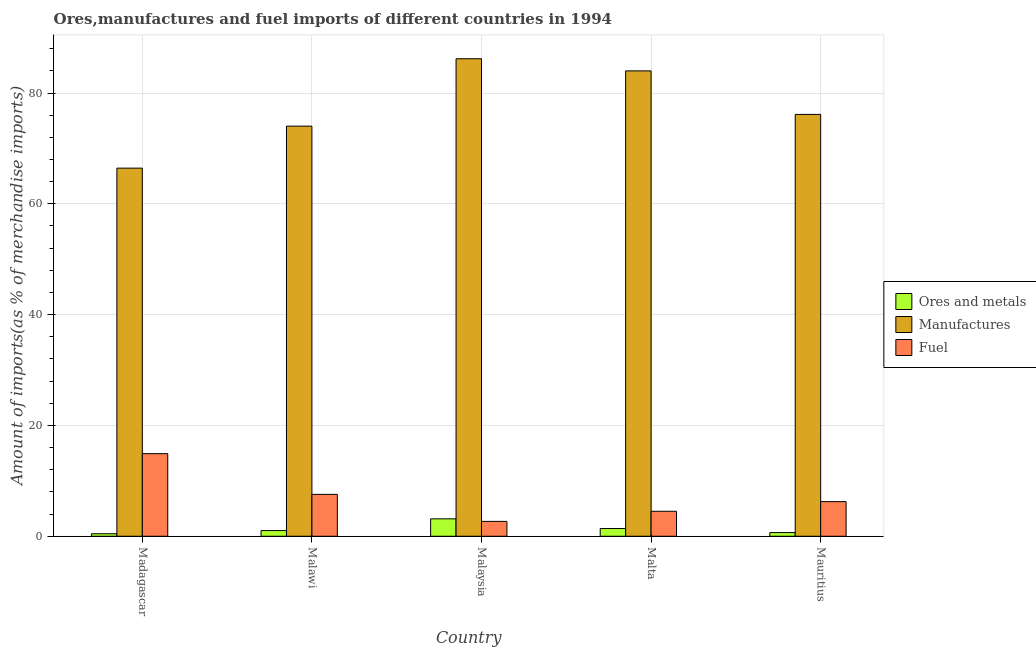How many different coloured bars are there?
Your answer should be very brief. 3. How many bars are there on the 2nd tick from the right?
Offer a very short reply. 3. What is the label of the 3rd group of bars from the left?
Offer a terse response. Malaysia. What is the percentage of fuel imports in Madagascar?
Your answer should be compact. 14.91. Across all countries, what is the maximum percentage of manufactures imports?
Offer a terse response. 86.19. Across all countries, what is the minimum percentage of fuel imports?
Your response must be concise. 2.68. In which country was the percentage of ores and metals imports maximum?
Your answer should be very brief. Malaysia. In which country was the percentage of fuel imports minimum?
Offer a terse response. Malaysia. What is the total percentage of fuel imports in the graph?
Ensure brevity in your answer.  35.9. What is the difference between the percentage of manufactures imports in Madagascar and that in Malaysia?
Provide a short and direct response. -19.74. What is the difference between the percentage of fuel imports in Madagascar and the percentage of ores and metals imports in Malta?
Provide a short and direct response. 13.51. What is the average percentage of ores and metals imports per country?
Your response must be concise. 1.34. What is the difference between the percentage of manufactures imports and percentage of fuel imports in Malta?
Offer a very short reply. 79.49. In how many countries, is the percentage of fuel imports greater than 12 %?
Your answer should be very brief. 1. What is the ratio of the percentage of ores and metals imports in Malawi to that in Mauritius?
Provide a succinct answer. 1.55. What is the difference between the highest and the second highest percentage of ores and metals imports?
Provide a succinct answer. 1.75. What is the difference between the highest and the lowest percentage of manufactures imports?
Ensure brevity in your answer.  19.74. In how many countries, is the percentage of manufactures imports greater than the average percentage of manufactures imports taken over all countries?
Your answer should be compact. 2. Is the sum of the percentage of fuel imports in Malawi and Malaysia greater than the maximum percentage of manufactures imports across all countries?
Give a very brief answer. No. What does the 1st bar from the left in Malawi represents?
Keep it short and to the point. Ores and metals. What does the 1st bar from the right in Malawi represents?
Offer a terse response. Fuel. Is it the case that in every country, the sum of the percentage of ores and metals imports and percentage of manufactures imports is greater than the percentage of fuel imports?
Your answer should be very brief. Yes. Are all the bars in the graph horizontal?
Give a very brief answer. No. How many countries are there in the graph?
Give a very brief answer. 5. What is the difference between two consecutive major ticks on the Y-axis?
Provide a succinct answer. 20. Does the graph contain grids?
Give a very brief answer. Yes. How are the legend labels stacked?
Keep it short and to the point. Vertical. What is the title of the graph?
Keep it short and to the point. Ores,manufactures and fuel imports of different countries in 1994. What is the label or title of the Y-axis?
Ensure brevity in your answer.  Amount of imports(as % of merchandise imports). What is the Amount of imports(as % of merchandise imports) in Ores and metals in Madagascar?
Make the answer very short. 0.45. What is the Amount of imports(as % of merchandise imports) in Manufactures in Madagascar?
Keep it short and to the point. 66.44. What is the Amount of imports(as % of merchandise imports) of Fuel in Madagascar?
Your answer should be very brief. 14.91. What is the Amount of imports(as % of merchandise imports) in Ores and metals in Malawi?
Keep it short and to the point. 1.03. What is the Amount of imports(as % of merchandise imports) in Manufactures in Malawi?
Make the answer very short. 74.02. What is the Amount of imports(as % of merchandise imports) of Fuel in Malawi?
Keep it short and to the point. 7.56. What is the Amount of imports(as % of merchandise imports) of Ores and metals in Malaysia?
Your answer should be very brief. 3.14. What is the Amount of imports(as % of merchandise imports) in Manufactures in Malaysia?
Offer a very short reply. 86.19. What is the Amount of imports(as % of merchandise imports) of Fuel in Malaysia?
Give a very brief answer. 2.68. What is the Amount of imports(as % of merchandise imports) in Ores and metals in Malta?
Give a very brief answer. 1.39. What is the Amount of imports(as % of merchandise imports) of Manufactures in Malta?
Offer a very short reply. 84. What is the Amount of imports(as % of merchandise imports) of Fuel in Malta?
Your answer should be very brief. 4.51. What is the Amount of imports(as % of merchandise imports) of Ores and metals in Mauritius?
Make the answer very short. 0.66. What is the Amount of imports(as % of merchandise imports) in Manufactures in Mauritius?
Offer a terse response. 76.14. What is the Amount of imports(as % of merchandise imports) in Fuel in Mauritius?
Your answer should be compact. 6.25. Across all countries, what is the maximum Amount of imports(as % of merchandise imports) in Ores and metals?
Offer a terse response. 3.14. Across all countries, what is the maximum Amount of imports(as % of merchandise imports) in Manufactures?
Provide a succinct answer. 86.19. Across all countries, what is the maximum Amount of imports(as % of merchandise imports) of Fuel?
Make the answer very short. 14.91. Across all countries, what is the minimum Amount of imports(as % of merchandise imports) of Ores and metals?
Give a very brief answer. 0.45. Across all countries, what is the minimum Amount of imports(as % of merchandise imports) of Manufactures?
Ensure brevity in your answer.  66.44. Across all countries, what is the minimum Amount of imports(as % of merchandise imports) in Fuel?
Provide a succinct answer. 2.68. What is the total Amount of imports(as % of merchandise imports) of Ores and metals in the graph?
Make the answer very short. 6.68. What is the total Amount of imports(as % of merchandise imports) in Manufactures in the graph?
Provide a short and direct response. 386.79. What is the total Amount of imports(as % of merchandise imports) of Fuel in the graph?
Make the answer very short. 35.9. What is the difference between the Amount of imports(as % of merchandise imports) in Ores and metals in Madagascar and that in Malawi?
Your answer should be compact. -0.57. What is the difference between the Amount of imports(as % of merchandise imports) in Manufactures in Madagascar and that in Malawi?
Offer a terse response. -7.58. What is the difference between the Amount of imports(as % of merchandise imports) of Fuel in Madagascar and that in Malawi?
Your response must be concise. 7.35. What is the difference between the Amount of imports(as % of merchandise imports) of Ores and metals in Madagascar and that in Malaysia?
Give a very brief answer. -2.69. What is the difference between the Amount of imports(as % of merchandise imports) in Manufactures in Madagascar and that in Malaysia?
Your response must be concise. -19.74. What is the difference between the Amount of imports(as % of merchandise imports) in Fuel in Madagascar and that in Malaysia?
Give a very brief answer. 12.23. What is the difference between the Amount of imports(as % of merchandise imports) of Ores and metals in Madagascar and that in Malta?
Provide a succinct answer. -0.94. What is the difference between the Amount of imports(as % of merchandise imports) of Manufactures in Madagascar and that in Malta?
Offer a terse response. -17.55. What is the difference between the Amount of imports(as % of merchandise imports) of Fuel in Madagascar and that in Malta?
Provide a succinct answer. 10.4. What is the difference between the Amount of imports(as % of merchandise imports) in Ores and metals in Madagascar and that in Mauritius?
Keep it short and to the point. -0.21. What is the difference between the Amount of imports(as % of merchandise imports) of Manufactures in Madagascar and that in Mauritius?
Your answer should be very brief. -9.7. What is the difference between the Amount of imports(as % of merchandise imports) in Fuel in Madagascar and that in Mauritius?
Provide a short and direct response. 8.66. What is the difference between the Amount of imports(as % of merchandise imports) of Ores and metals in Malawi and that in Malaysia?
Make the answer very short. -2.12. What is the difference between the Amount of imports(as % of merchandise imports) of Manufactures in Malawi and that in Malaysia?
Provide a succinct answer. -12.16. What is the difference between the Amount of imports(as % of merchandise imports) in Fuel in Malawi and that in Malaysia?
Provide a short and direct response. 4.87. What is the difference between the Amount of imports(as % of merchandise imports) in Ores and metals in Malawi and that in Malta?
Your answer should be very brief. -0.37. What is the difference between the Amount of imports(as % of merchandise imports) of Manufactures in Malawi and that in Malta?
Give a very brief answer. -9.97. What is the difference between the Amount of imports(as % of merchandise imports) in Fuel in Malawi and that in Malta?
Keep it short and to the point. 3.05. What is the difference between the Amount of imports(as % of merchandise imports) of Ores and metals in Malawi and that in Mauritius?
Give a very brief answer. 0.36. What is the difference between the Amount of imports(as % of merchandise imports) in Manufactures in Malawi and that in Mauritius?
Your answer should be very brief. -2.12. What is the difference between the Amount of imports(as % of merchandise imports) of Fuel in Malawi and that in Mauritius?
Keep it short and to the point. 1.31. What is the difference between the Amount of imports(as % of merchandise imports) of Ores and metals in Malaysia and that in Malta?
Keep it short and to the point. 1.75. What is the difference between the Amount of imports(as % of merchandise imports) in Manufactures in Malaysia and that in Malta?
Offer a terse response. 2.19. What is the difference between the Amount of imports(as % of merchandise imports) of Fuel in Malaysia and that in Malta?
Give a very brief answer. -1.82. What is the difference between the Amount of imports(as % of merchandise imports) of Ores and metals in Malaysia and that in Mauritius?
Keep it short and to the point. 2.48. What is the difference between the Amount of imports(as % of merchandise imports) of Manufactures in Malaysia and that in Mauritius?
Offer a terse response. 10.05. What is the difference between the Amount of imports(as % of merchandise imports) of Fuel in Malaysia and that in Mauritius?
Offer a terse response. -3.57. What is the difference between the Amount of imports(as % of merchandise imports) of Ores and metals in Malta and that in Mauritius?
Your response must be concise. 0.73. What is the difference between the Amount of imports(as % of merchandise imports) of Manufactures in Malta and that in Mauritius?
Keep it short and to the point. 7.86. What is the difference between the Amount of imports(as % of merchandise imports) of Fuel in Malta and that in Mauritius?
Provide a short and direct response. -1.74. What is the difference between the Amount of imports(as % of merchandise imports) of Ores and metals in Madagascar and the Amount of imports(as % of merchandise imports) of Manufactures in Malawi?
Keep it short and to the point. -73.57. What is the difference between the Amount of imports(as % of merchandise imports) in Ores and metals in Madagascar and the Amount of imports(as % of merchandise imports) in Fuel in Malawi?
Your answer should be very brief. -7.1. What is the difference between the Amount of imports(as % of merchandise imports) of Manufactures in Madagascar and the Amount of imports(as % of merchandise imports) of Fuel in Malawi?
Your answer should be compact. 58.89. What is the difference between the Amount of imports(as % of merchandise imports) of Ores and metals in Madagascar and the Amount of imports(as % of merchandise imports) of Manufactures in Malaysia?
Provide a succinct answer. -85.73. What is the difference between the Amount of imports(as % of merchandise imports) in Ores and metals in Madagascar and the Amount of imports(as % of merchandise imports) in Fuel in Malaysia?
Provide a succinct answer. -2.23. What is the difference between the Amount of imports(as % of merchandise imports) of Manufactures in Madagascar and the Amount of imports(as % of merchandise imports) of Fuel in Malaysia?
Your response must be concise. 63.76. What is the difference between the Amount of imports(as % of merchandise imports) of Ores and metals in Madagascar and the Amount of imports(as % of merchandise imports) of Manufactures in Malta?
Your response must be concise. -83.54. What is the difference between the Amount of imports(as % of merchandise imports) of Ores and metals in Madagascar and the Amount of imports(as % of merchandise imports) of Fuel in Malta?
Your answer should be compact. -4.05. What is the difference between the Amount of imports(as % of merchandise imports) in Manufactures in Madagascar and the Amount of imports(as % of merchandise imports) in Fuel in Malta?
Ensure brevity in your answer.  61.94. What is the difference between the Amount of imports(as % of merchandise imports) in Ores and metals in Madagascar and the Amount of imports(as % of merchandise imports) in Manufactures in Mauritius?
Make the answer very short. -75.69. What is the difference between the Amount of imports(as % of merchandise imports) in Ores and metals in Madagascar and the Amount of imports(as % of merchandise imports) in Fuel in Mauritius?
Your answer should be compact. -5.8. What is the difference between the Amount of imports(as % of merchandise imports) of Manufactures in Madagascar and the Amount of imports(as % of merchandise imports) of Fuel in Mauritius?
Your response must be concise. 60.19. What is the difference between the Amount of imports(as % of merchandise imports) of Ores and metals in Malawi and the Amount of imports(as % of merchandise imports) of Manufactures in Malaysia?
Offer a very short reply. -85.16. What is the difference between the Amount of imports(as % of merchandise imports) in Ores and metals in Malawi and the Amount of imports(as % of merchandise imports) in Fuel in Malaysia?
Give a very brief answer. -1.66. What is the difference between the Amount of imports(as % of merchandise imports) in Manufactures in Malawi and the Amount of imports(as % of merchandise imports) in Fuel in Malaysia?
Offer a very short reply. 71.34. What is the difference between the Amount of imports(as % of merchandise imports) of Ores and metals in Malawi and the Amount of imports(as % of merchandise imports) of Manufactures in Malta?
Give a very brief answer. -82.97. What is the difference between the Amount of imports(as % of merchandise imports) in Ores and metals in Malawi and the Amount of imports(as % of merchandise imports) in Fuel in Malta?
Ensure brevity in your answer.  -3.48. What is the difference between the Amount of imports(as % of merchandise imports) of Manufactures in Malawi and the Amount of imports(as % of merchandise imports) of Fuel in Malta?
Make the answer very short. 69.52. What is the difference between the Amount of imports(as % of merchandise imports) of Ores and metals in Malawi and the Amount of imports(as % of merchandise imports) of Manufactures in Mauritius?
Your answer should be very brief. -75.12. What is the difference between the Amount of imports(as % of merchandise imports) in Ores and metals in Malawi and the Amount of imports(as % of merchandise imports) in Fuel in Mauritius?
Your answer should be very brief. -5.22. What is the difference between the Amount of imports(as % of merchandise imports) of Manufactures in Malawi and the Amount of imports(as % of merchandise imports) of Fuel in Mauritius?
Keep it short and to the point. 67.77. What is the difference between the Amount of imports(as % of merchandise imports) in Ores and metals in Malaysia and the Amount of imports(as % of merchandise imports) in Manufactures in Malta?
Make the answer very short. -80.85. What is the difference between the Amount of imports(as % of merchandise imports) in Ores and metals in Malaysia and the Amount of imports(as % of merchandise imports) in Fuel in Malta?
Provide a short and direct response. -1.36. What is the difference between the Amount of imports(as % of merchandise imports) of Manufactures in Malaysia and the Amount of imports(as % of merchandise imports) of Fuel in Malta?
Keep it short and to the point. 81.68. What is the difference between the Amount of imports(as % of merchandise imports) in Ores and metals in Malaysia and the Amount of imports(as % of merchandise imports) in Manufactures in Mauritius?
Provide a succinct answer. -73. What is the difference between the Amount of imports(as % of merchandise imports) of Ores and metals in Malaysia and the Amount of imports(as % of merchandise imports) of Fuel in Mauritius?
Your response must be concise. -3.11. What is the difference between the Amount of imports(as % of merchandise imports) of Manufactures in Malaysia and the Amount of imports(as % of merchandise imports) of Fuel in Mauritius?
Give a very brief answer. 79.94. What is the difference between the Amount of imports(as % of merchandise imports) in Ores and metals in Malta and the Amount of imports(as % of merchandise imports) in Manufactures in Mauritius?
Your response must be concise. -74.75. What is the difference between the Amount of imports(as % of merchandise imports) of Ores and metals in Malta and the Amount of imports(as % of merchandise imports) of Fuel in Mauritius?
Ensure brevity in your answer.  -4.86. What is the difference between the Amount of imports(as % of merchandise imports) of Manufactures in Malta and the Amount of imports(as % of merchandise imports) of Fuel in Mauritius?
Offer a terse response. 77.75. What is the average Amount of imports(as % of merchandise imports) of Ores and metals per country?
Offer a very short reply. 1.34. What is the average Amount of imports(as % of merchandise imports) in Manufactures per country?
Your answer should be very brief. 77.36. What is the average Amount of imports(as % of merchandise imports) in Fuel per country?
Your answer should be very brief. 7.18. What is the difference between the Amount of imports(as % of merchandise imports) in Ores and metals and Amount of imports(as % of merchandise imports) in Manufactures in Madagascar?
Your answer should be very brief. -65.99. What is the difference between the Amount of imports(as % of merchandise imports) of Ores and metals and Amount of imports(as % of merchandise imports) of Fuel in Madagascar?
Provide a succinct answer. -14.46. What is the difference between the Amount of imports(as % of merchandise imports) of Manufactures and Amount of imports(as % of merchandise imports) of Fuel in Madagascar?
Provide a short and direct response. 51.53. What is the difference between the Amount of imports(as % of merchandise imports) in Ores and metals and Amount of imports(as % of merchandise imports) in Manufactures in Malawi?
Offer a terse response. -73. What is the difference between the Amount of imports(as % of merchandise imports) of Ores and metals and Amount of imports(as % of merchandise imports) of Fuel in Malawi?
Your answer should be compact. -6.53. What is the difference between the Amount of imports(as % of merchandise imports) in Manufactures and Amount of imports(as % of merchandise imports) in Fuel in Malawi?
Your answer should be very brief. 66.47. What is the difference between the Amount of imports(as % of merchandise imports) in Ores and metals and Amount of imports(as % of merchandise imports) in Manufactures in Malaysia?
Your answer should be very brief. -83.04. What is the difference between the Amount of imports(as % of merchandise imports) of Ores and metals and Amount of imports(as % of merchandise imports) of Fuel in Malaysia?
Keep it short and to the point. 0.46. What is the difference between the Amount of imports(as % of merchandise imports) of Manufactures and Amount of imports(as % of merchandise imports) of Fuel in Malaysia?
Give a very brief answer. 83.5. What is the difference between the Amount of imports(as % of merchandise imports) in Ores and metals and Amount of imports(as % of merchandise imports) in Manufactures in Malta?
Provide a succinct answer. -82.6. What is the difference between the Amount of imports(as % of merchandise imports) in Ores and metals and Amount of imports(as % of merchandise imports) in Fuel in Malta?
Provide a short and direct response. -3.11. What is the difference between the Amount of imports(as % of merchandise imports) of Manufactures and Amount of imports(as % of merchandise imports) of Fuel in Malta?
Make the answer very short. 79.49. What is the difference between the Amount of imports(as % of merchandise imports) of Ores and metals and Amount of imports(as % of merchandise imports) of Manufactures in Mauritius?
Ensure brevity in your answer.  -75.48. What is the difference between the Amount of imports(as % of merchandise imports) in Ores and metals and Amount of imports(as % of merchandise imports) in Fuel in Mauritius?
Ensure brevity in your answer.  -5.59. What is the difference between the Amount of imports(as % of merchandise imports) in Manufactures and Amount of imports(as % of merchandise imports) in Fuel in Mauritius?
Make the answer very short. 69.89. What is the ratio of the Amount of imports(as % of merchandise imports) of Ores and metals in Madagascar to that in Malawi?
Offer a terse response. 0.44. What is the ratio of the Amount of imports(as % of merchandise imports) of Manufactures in Madagascar to that in Malawi?
Provide a short and direct response. 0.9. What is the ratio of the Amount of imports(as % of merchandise imports) in Fuel in Madagascar to that in Malawi?
Your answer should be compact. 1.97. What is the ratio of the Amount of imports(as % of merchandise imports) in Ores and metals in Madagascar to that in Malaysia?
Provide a succinct answer. 0.14. What is the ratio of the Amount of imports(as % of merchandise imports) in Manufactures in Madagascar to that in Malaysia?
Make the answer very short. 0.77. What is the ratio of the Amount of imports(as % of merchandise imports) in Fuel in Madagascar to that in Malaysia?
Keep it short and to the point. 5.56. What is the ratio of the Amount of imports(as % of merchandise imports) of Ores and metals in Madagascar to that in Malta?
Provide a succinct answer. 0.32. What is the ratio of the Amount of imports(as % of merchandise imports) of Manufactures in Madagascar to that in Malta?
Your response must be concise. 0.79. What is the ratio of the Amount of imports(as % of merchandise imports) in Fuel in Madagascar to that in Malta?
Give a very brief answer. 3.31. What is the ratio of the Amount of imports(as % of merchandise imports) in Ores and metals in Madagascar to that in Mauritius?
Give a very brief answer. 0.68. What is the ratio of the Amount of imports(as % of merchandise imports) in Manufactures in Madagascar to that in Mauritius?
Your answer should be compact. 0.87. What is the ratio of the Amount of imports(as % of merchandise imports) in Fuel in Madagascar to that in Mauritius?
Give a very brief answer. 2.39. What is the ratio of the Amount of imports(as % of merchandise imports) in Ores and metals in Malawi to that in Malaysia?
Provide a short and direct response. 0.33. What is the ratio of the Amount of imports(as % of merchandise imports) in Manufactures in Malawi to that in Malaysia?
Make the answer very short. 0.86. What is the ratio of the Amount of imports(as % of merchandise imports) of Fuel in Malawi to that in Malaysia?
Offer a terse response. 2.82. What is the ratio of the Amount of imports(as % of merchandise imports) of Ores and metals in Malawi to that in Malta?
Ensure brevity in your answer.  0.73. What is the ratio of the Amount of imports(as % of merchandise imports) of Manufactures in Malawi to that in Malta?
Make the answer very short. 0.88. What is the ratio of the Amount of imports(as % of merchandise imports) in Fuel in Malawi to that in Malta?
Your response must be concise. 1.68. What is the ratio of the Amount of imports(as % of merchandise imports) in Ores and metals in Malawi to that in Mauritius?
Your answer should be compact. 1.55. What is the ratio of the Amount of imports(as % of merchandise imports) of Manufactures in Malawi to that in Mauritius?
Make the answer very short. 0.97. What is the ratio of the Amount of imports(as % of merchandise imports) in Fuel in Malawi to that in Mauritius?
Make the answer very short. 1.21. What is the ratio of the Amount of imports(as % of merchandise imports) of Ores and metals in Malaysia to that in Malta?
Offer a very short reply. 2.25. What is the ratio of the Amount of imports(as % of merchandise imports) of Manufactures in Malaysia to that in Malta?
Make the answer very short. 1.03. What is the ratio of the Amount of imports(as % of merchandise imports) of Fuel in Malaysia to that in Malta?
Make the answer very short. 0.6. What is the ratio of the Amount of imports(as % of merchandise imports) of Ores and metals in Malaysia to that in Mauritius?
Your response must be concise. 4.75. What is the ratio of the Amount of imports(as % of merchandise imports) of Manufactures in Malaysia to that in Mauritius?
Give a very brief answer. 1.13. What is the ratio of the Amount of imports(as % of merchandise imports) in Fuel in Malaysia to that in Mauritius?
Keep it short and to the point. 0.43. What is the ratio of the Amount of imports(as % of merchandise imports) in Ores and metals in Malta to that in Mauritius?
Offer a very short reply. 2.11. What is the ratio of the Amount of imports(as % of merchandise imports) of Manufactures in Malta to that in Mauritius?
Offer a very short reply. 1.1. What is the ratio of the Amount of imports(as % of merchandise imports) in Fuel in Malta to that in Mauritius?
Keep it short and to the point. 0.72. What is the difference between the highest and the second highest Amount of imports(as % of merchandise imports) in Ores and metals?
Ensure brevity in your answer.  1.75. What is the difference between the highest and the second highest Amount of imports(as % of merchandise imports) in Manufactures?
Offer a very short reply. 2.19. What is the difference between the highest and the second highest Amount of imports(as % of merchandise imports) in Fuel?
Ensure brevity in your answer.  7.35. What is the difference between the highest and the lowest Amount of imports(as % of merchandise imports) of Ores and metals?
Ensure brevity in your answer.  2.69. What is the difference between the highest and the lowest Amount of imports(as % of merchandise imports) in Manufactures?
Keep it short and to the point. 19.74. What is the difference between the highest and the lowest Amount of imports(as % of merchandise imports) in Fuel?
Your answer should be compact. 12.23. 